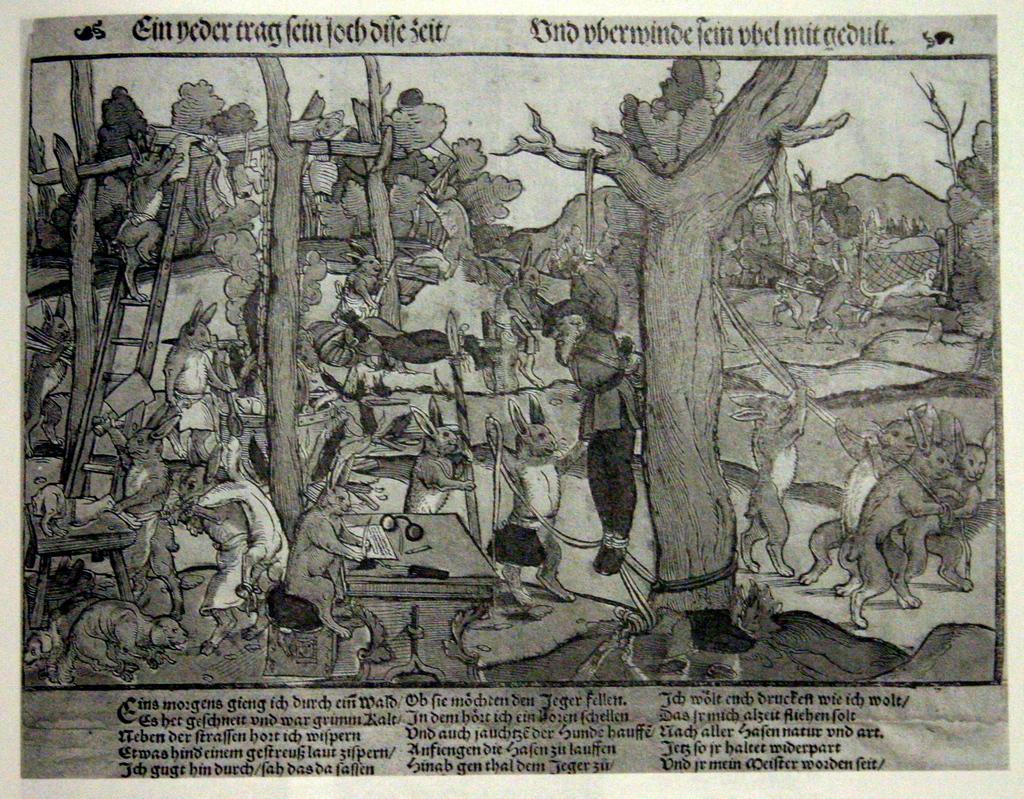How would you summarize this image in a sentence or two? This image contains a poster having some painting and some text. There are few rabbits and few animals are on the land having few trees and wooden trunks. Left side a rabbit is climbing the ladder. Beside the ladder a rabbit is holding a knife and holding an animal with the other hand. An animal is on the table. A rabbit is sitting on the stool. Before it there is a table having a paper and spectacles are on it. An animal is tied to a rope. Few rabbits are dragging the rope. Bottom of the image there is some text. 